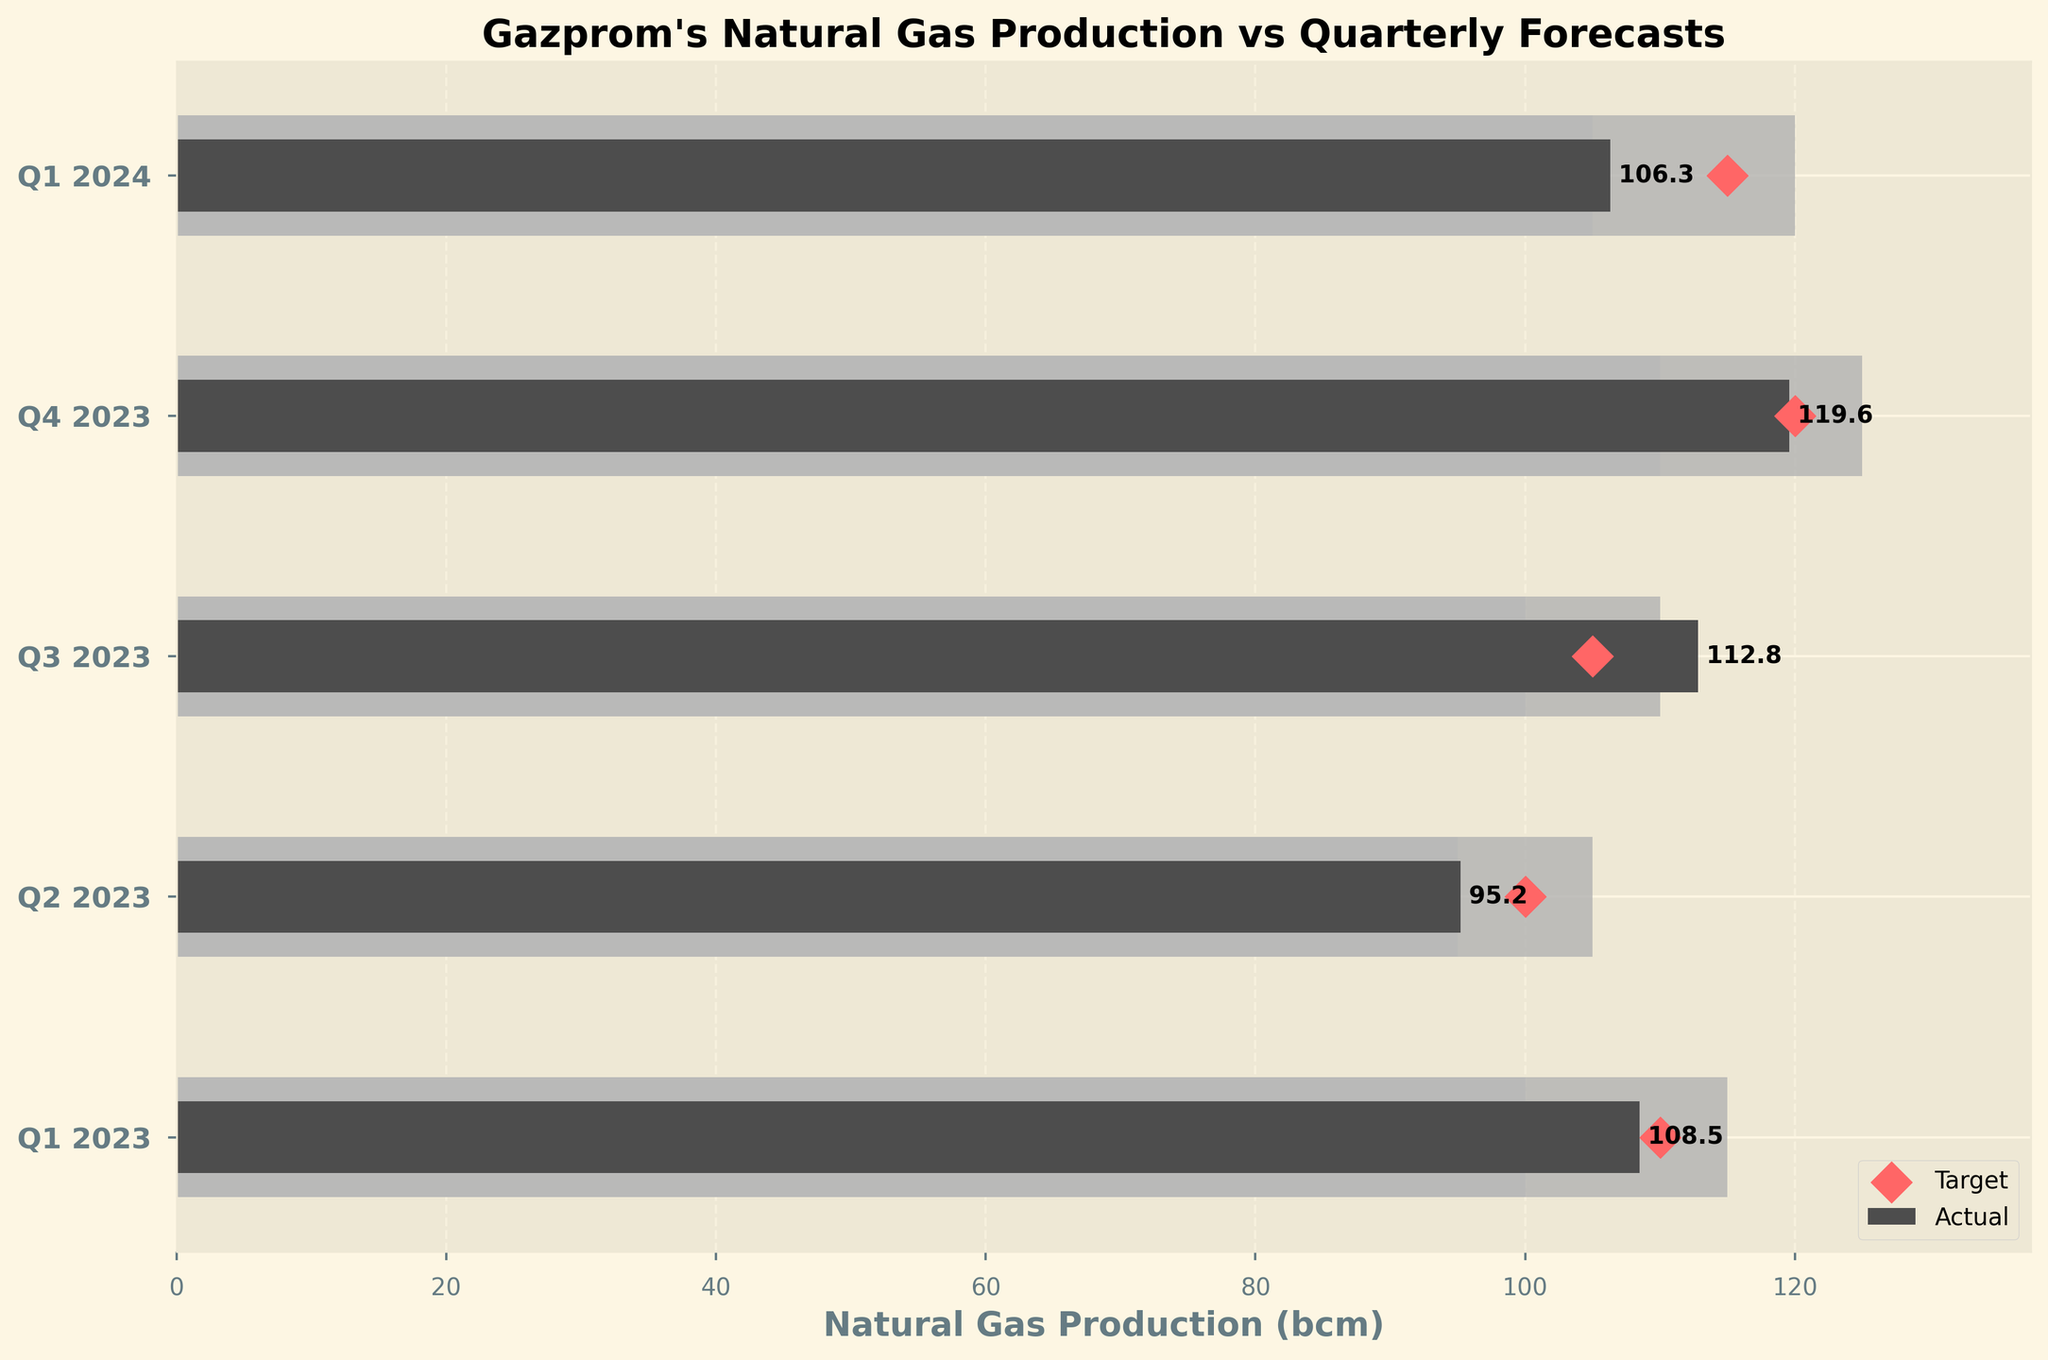What is the title of the chart? The title can be found at the top of the chart. It summarizes the content of the chart.
Answer: Gazprom's Natural Gas Production vs Quarterly Forecasts How many quarters are represented in the chart? Count the number of unique categories on the y-axis.
Answer: 5 What is the natural gas production for Q1 2023? Look at the bar corresponding to Q1 2023 and note the value.
Answer: 108.5 Which quarter had the highest natural gas production, and what was the value? Compare the lengths of the bars for each quarter to find the longest one.
Answer: Q4 2023, 119.6 Is there any quarter where the actual production meets the target exactly? Check if the actual production value matches the target value for any quarter.
Answer: No In which quarter was the actual natural gas production closest to the target? Calculate the absolute difference between actual production and the target for each quarter and find the minimum.
Answer: Q1 2023 What is the difference between the actual and target production in Q2 2023? Subtract the actual production from the target production for Q2 2023.
Answer: 4.8 For Q1 2024, how does the actual production compare to the "Range3" value? Check if the actual production value is above, below, or within the "Range3" value for Q1 2024.
Answer: Below Identify which quarter had the lowest target production? Compare the target production values for each quarter and find the minimum.
Answer: Q2 2023 By how much did the actual production in Q3 2023 exceed the "Range3" value? Subtract the "Range3" value for Q3 2023 from the actual production value of Q3 2023.
Answer: 2.8 